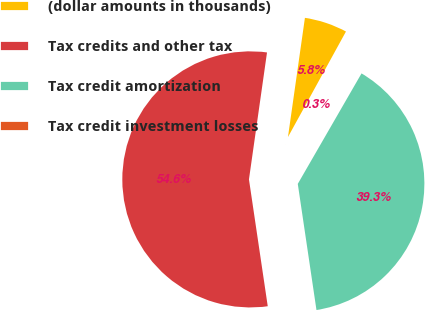<chart> <loc_0><loc_0><loc_500><loc_500><pie_chart><fcel>(dollar amounts in thousands)<fcel>Tax credits and other tax<fcel>Tax credit amortization<fcel>Tax credit investment losses<nl><fcel>5.75%<fcel>54.59%<fcel>39.33%<fcel>0.33%<nl></chart> 